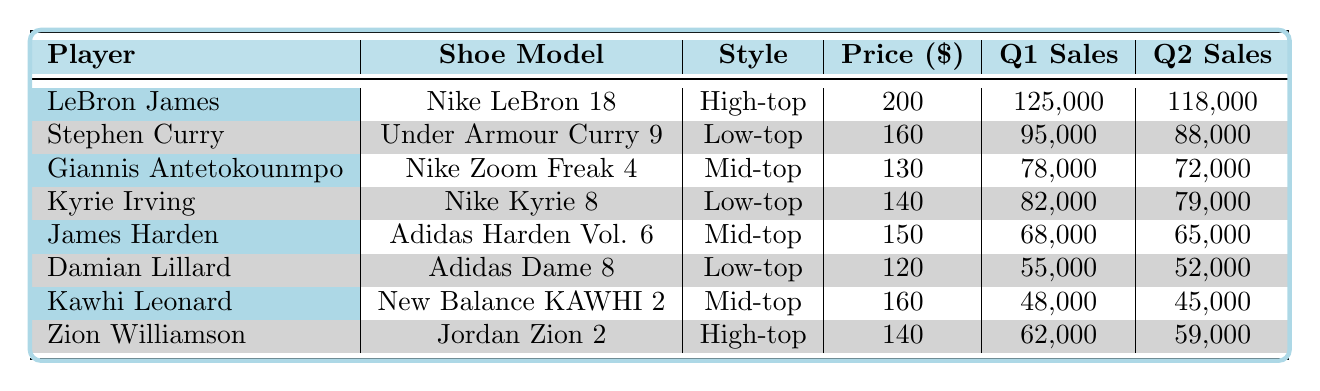What is the total number of units sold for LeBron James' shoes across both quarters? To find the total units sold for LeBron James, add the units sold in Q1 (125000) and Q2 (118000). So, 125000 + 118000 = 243000.
Answer: 243000 Which player's shoes had the lowest sales in Q2? Looking through Q2 sales data, the lowest units sold is from Zion Williamson (59000).
Answer: Zion Williamson What is the price difference between the most expensive and least expensive shoe models? The highest priced shoe is Nike LeBron 18 at 200, and the lowest priced is Adidas Dame 8 at 120. So, the difference is 200 - 120 = 80.
Answer: 80 Did Stephen Curry's shoe sales increase or decrease from Q1 to Q2? In Q1, Stephen Curry sold 95000 units, but in Q2, he sold 88000 units, indicating a decrease.
Answer: Decrease What percentage of sales did Giannis Antetokounmpo achieve in Q1 compared to the total sales of all players in Q1? First, sum all Q1 sales: 125000 + 95000 + 78000 + 82000 + 68000 + 55000 + 48000 + 62000 =  496000. Giannis sold 78000 units, so the percentage is (78000/496000) * 100 = 15.71%.
Answer: 15.71% How many units did Kyrie Irving sell more than Kawhi Leonard in Q1? Kyrie Irving sold 82000 units in Q1, while Kawhi Leonard sold 48000 units. The difference is 82000 - 48000 = 34000.
Answer: 34000 Are there any players who had the same number of sales in both quarters? Checking the sales figures, no player had identical sales in Q1 and Q2 according to the data given; each player showed a change in units sold.
Answer: No Which player had the highest total sales over both quarters? To find the top seller, add units for each player across both quarters. LeBron James has 243000, Stephen Curry has 183000, Giannis Antetokounmpo has 150000, Kyrie Irving has 161000, James Harden has 133000, Damian Lillard has 107000, Kawhi Leonard has 93000, and Zion Williamson has 121000. Clearly, LeBron James leads with 243000.
Answer: LeBron James 